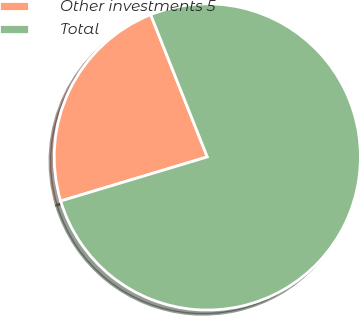Convert chart. <chart><loc_0><loc_0><loc_500><loc_500><pie_chart><fcel>Other investments 5<fcel>Total<nl><fcel>23.62%<fcel>76.38%<nl></chart> 